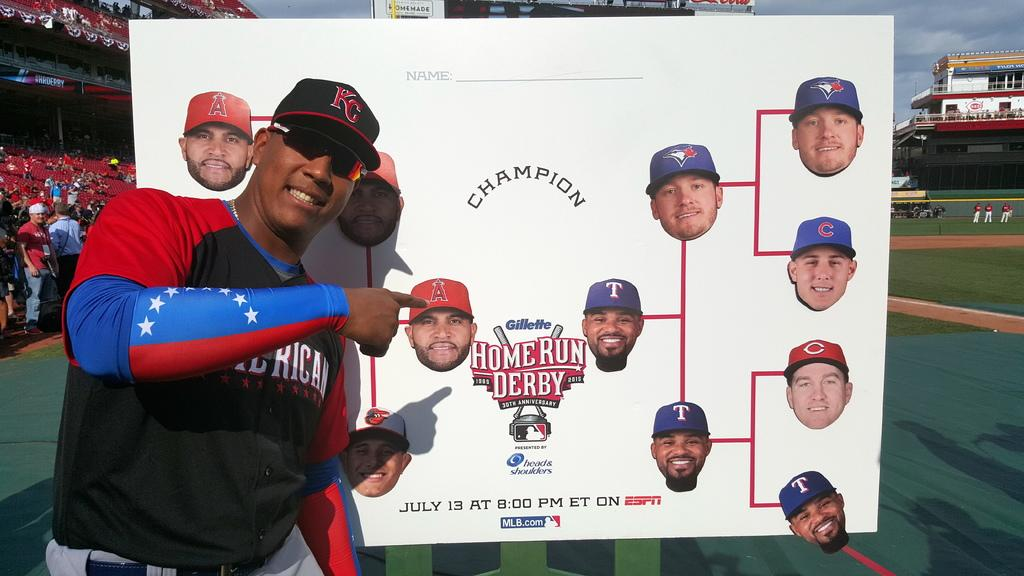<image>
Render a clear and concise summary of the photo. A tournament ladder for the home run derby with a man posing next to it. 